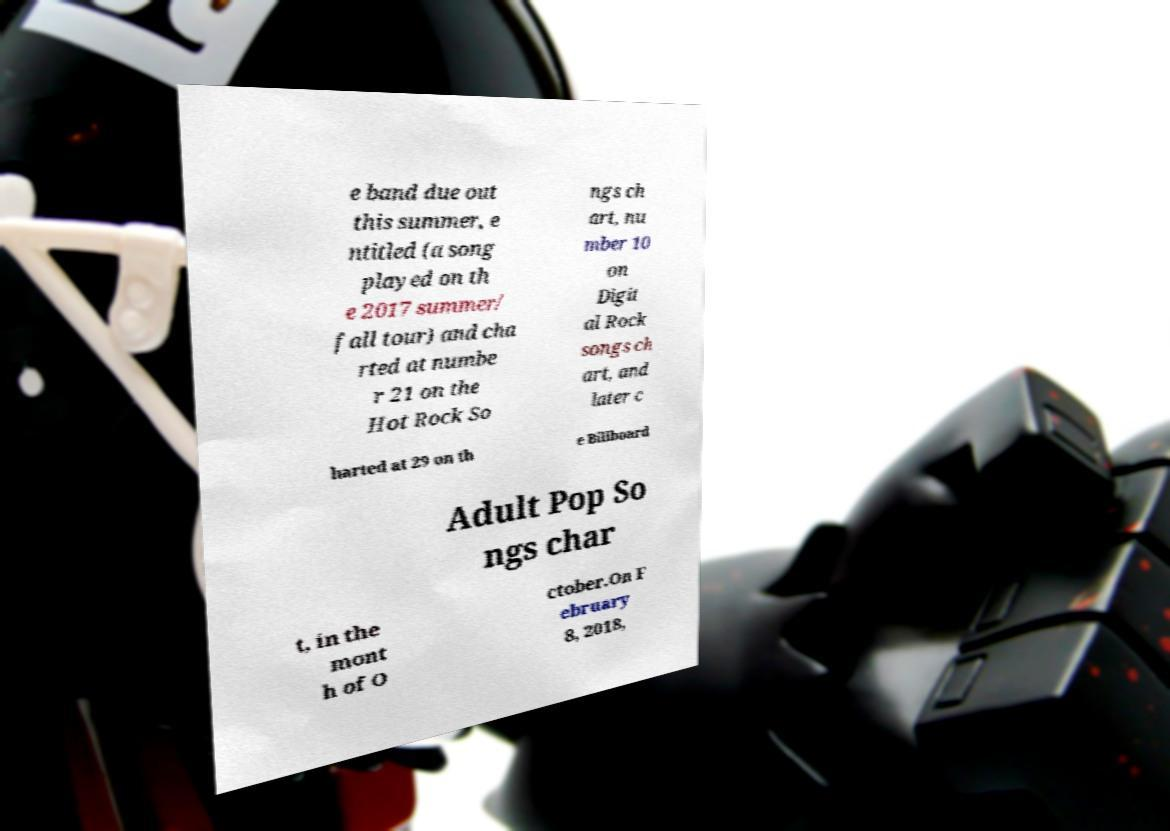What messages or text are displayed in this image? I need them in a readable, typed format. e band due out this summer, e ntitled (a song played on th e 2017 summer/ fall tour) and cha rted at numbe r 21 on the Hot Rock So ngs ch art, nu mber 10 on Digit al Rock songs ch art, and later c harted at 29 on th e Billboard Adult Pop So ngs char t, in the mont h of O ctober.On F ebruary 8, 2018, 